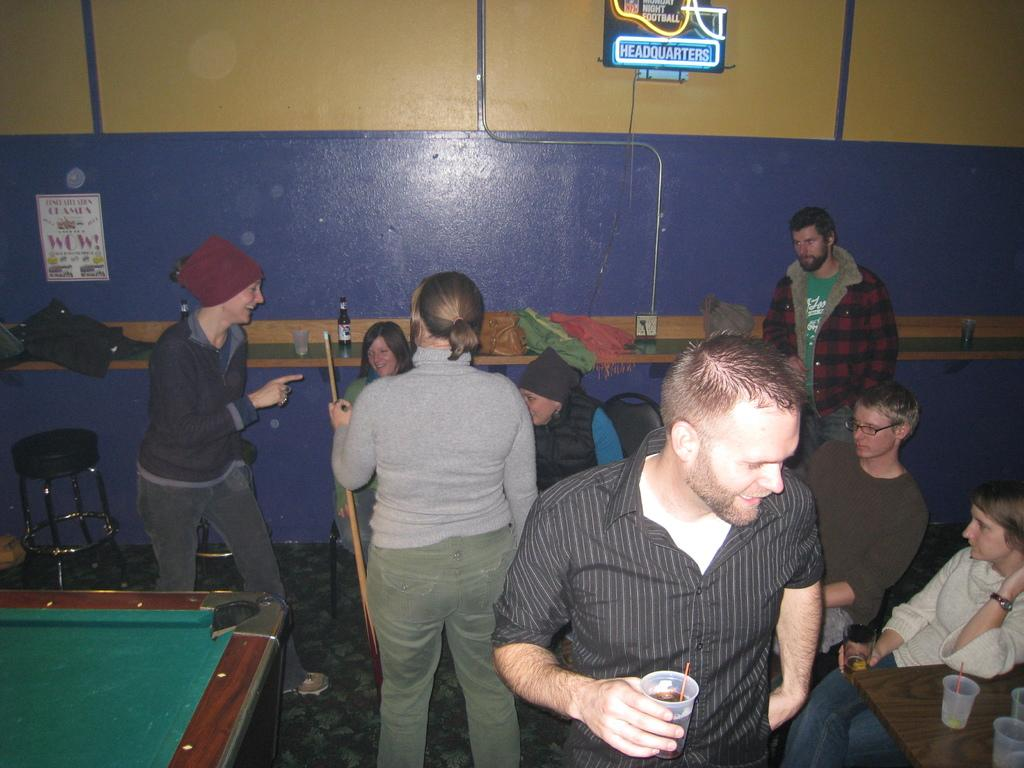How many people are in the image? There is a group of people in the image. What can be seen on the wall in the background? There is a poster on the wall in the background. What objects are on the table in the image? There is a bottle, a glass, a bag, and clothes on the table. What piece of furniture is on the left side of the image? There is a stool on the left side of the image. How many pizzas are being served on the table in the image? There is no mention of pizzas in the image; the objects on the table include a bottle, a glass, a bag, and clothes. What type of celery is being used as a decoration on the poster in the background? There is no celery present in the image; the poster features a design or image, but no specific details about its content are provided. 